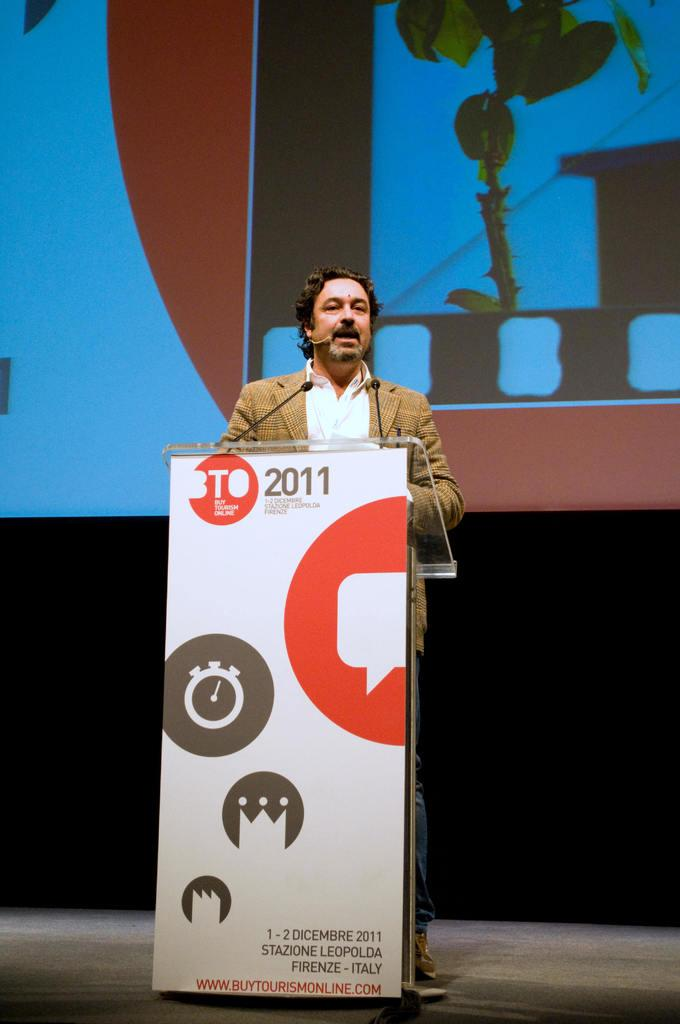<image>
Share a concise interpretation of the image provided. A person at a podium that has a banner which read BTO 2011 